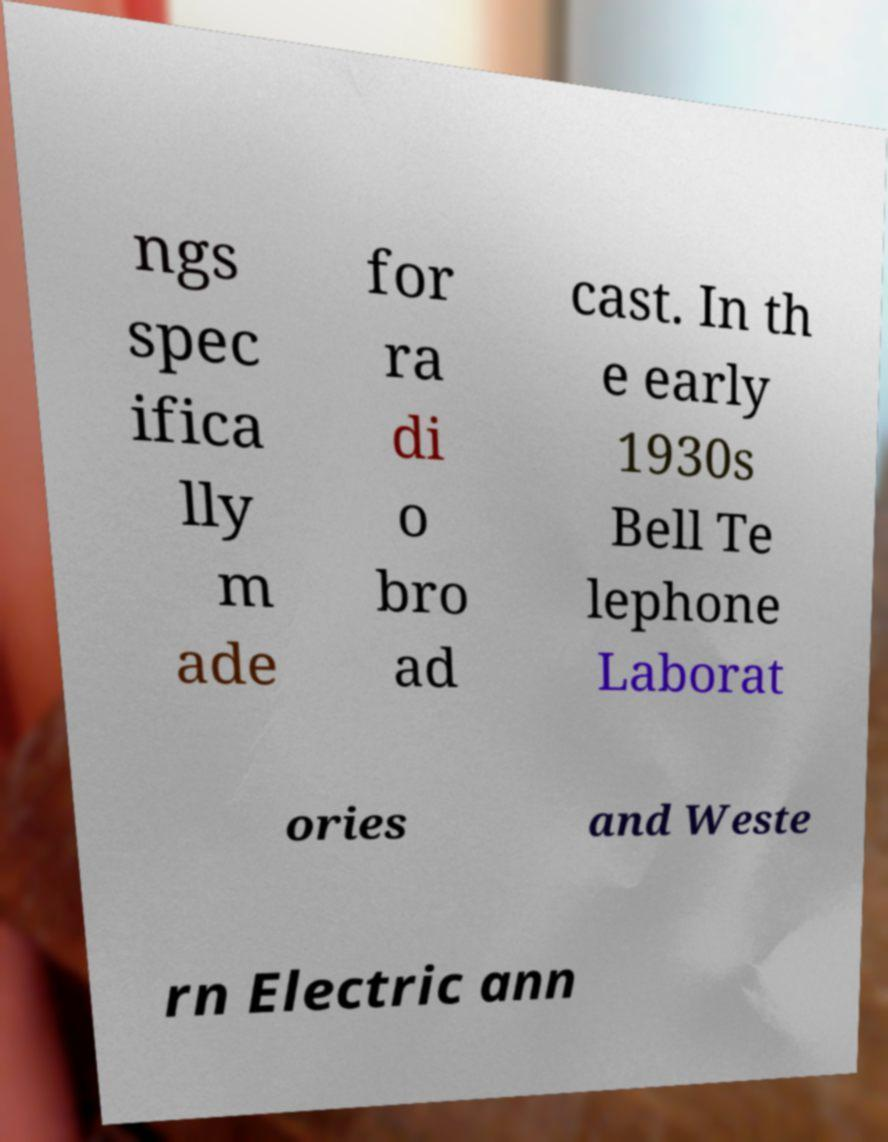There's text embedded in this image that I need extracted. Can you transcribe it verbatim? ngs spec ifica lly m ade for ra di o bro ad cast. In th e early 1930s Bell Te lephone Laborat ories and Weste rn Electric ann 